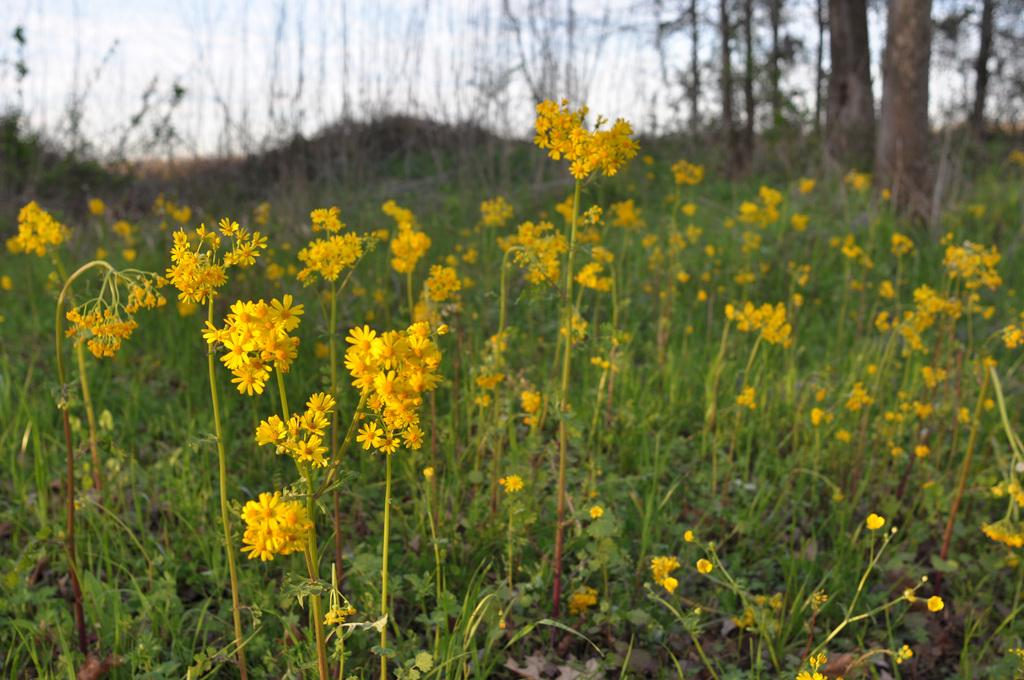What type of flowers can be seen in the image? There are yellow color flowers in the image. What other plant life is present in the image? There are plants in the image. What can be seen in the background of the image? There are trees in the background of the image. What is visible in the sky in the image? The sky is visible in the image and appears to be white in color. Where is the pan located in the image? There is no pan present in the image. What type of sofa can be seen in the image? There is no sofa present in the image. 